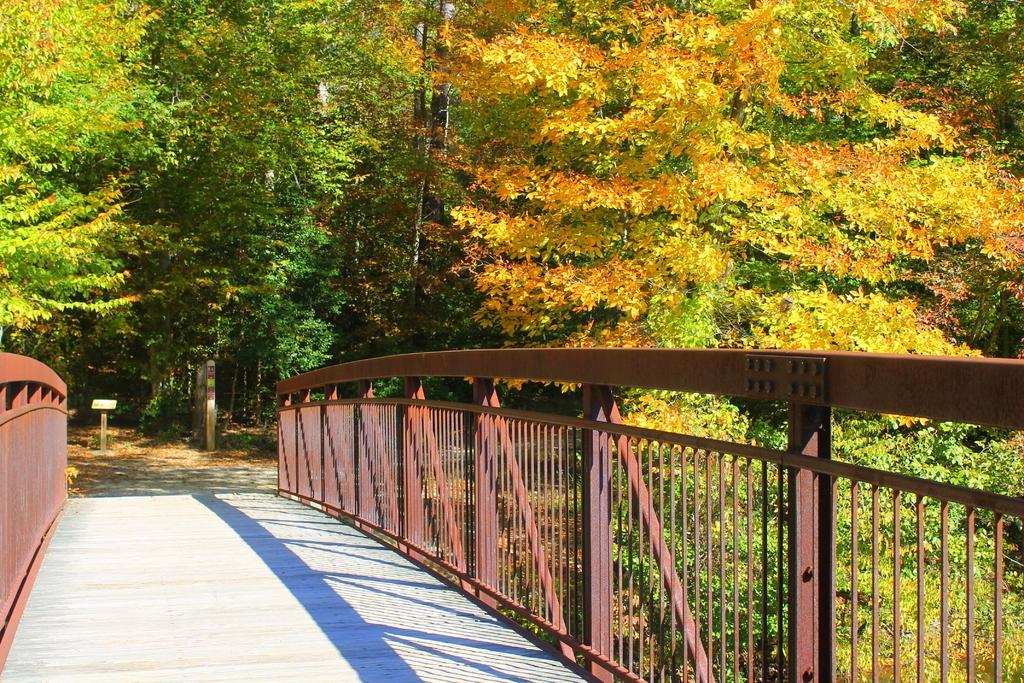Can you describe this image briefly? In this picture we can see trees, podium, wall and railings. 